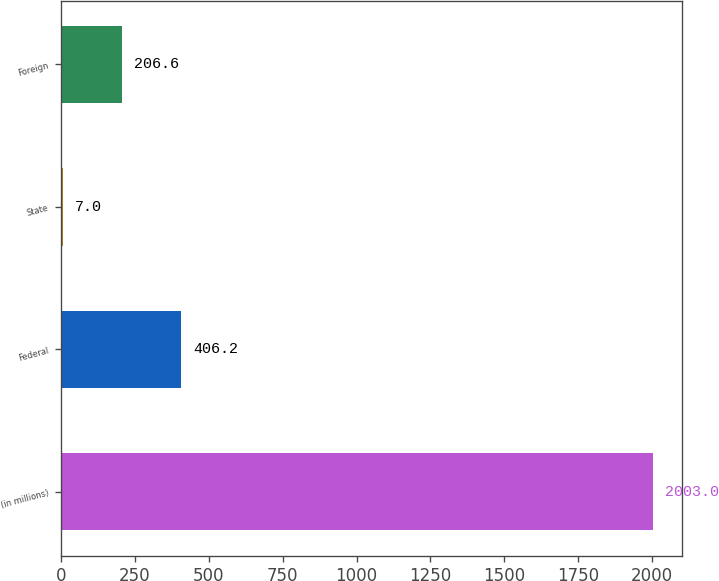<chart> <loc_0><loc_0><loc_500><loc_500><bar_chart><fcel>(in millions)<fcel>Federal<fcel>State<fcel>Foreign<nl><fcel>2003<fcel>406.2<fcel>7<fcel>206.6<nl></chart> 